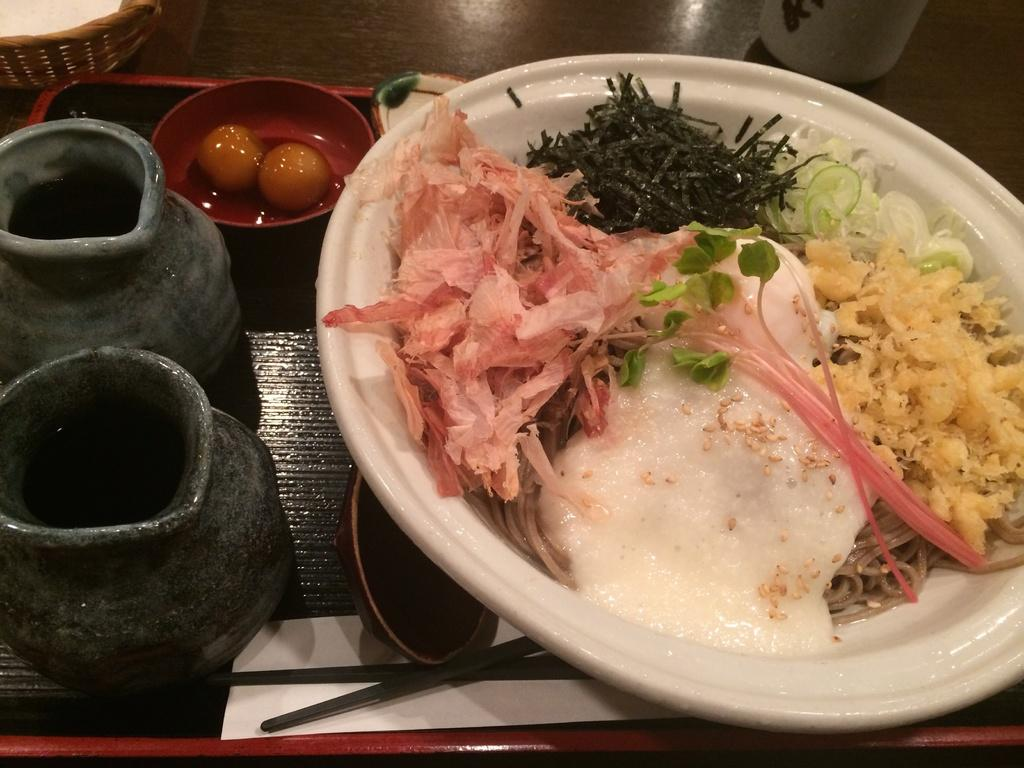What is on the serving plate in the image? There is food on the serving plate in the image. What is in the bowl that is visible in the image? There is a bowl with egg yolks in the image. What can be used for eating the food in the image? Cutlery is visible in the image. What type of print can be seen on the egg yolks in the image? There is no print on the egg yolks in the image; they are simply egg yolks in a bowl. In what position are the egg yolks arranged on the plate in the image? The egg yolks are not arranged on a plate in the image; they are in a bowl. 